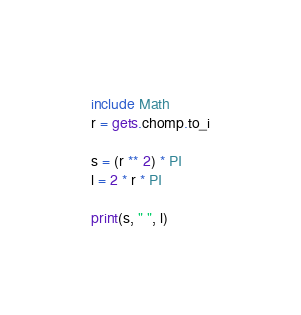<code> <loc_0><loc_0><loc_500><loc_500><_Ruby_>include Math
r = gets.chomp.to_i

s = (r ** 2) * PI
l = 2 * r * PI

print(s, " ", l)</code> 